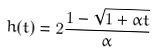<formula> <loc_0><loc_0><loc_500><loc_500>h ( t ) = 2 \frac { 1 - \sqrt { 1 + \alpha t } } { \alpha }</formula> 